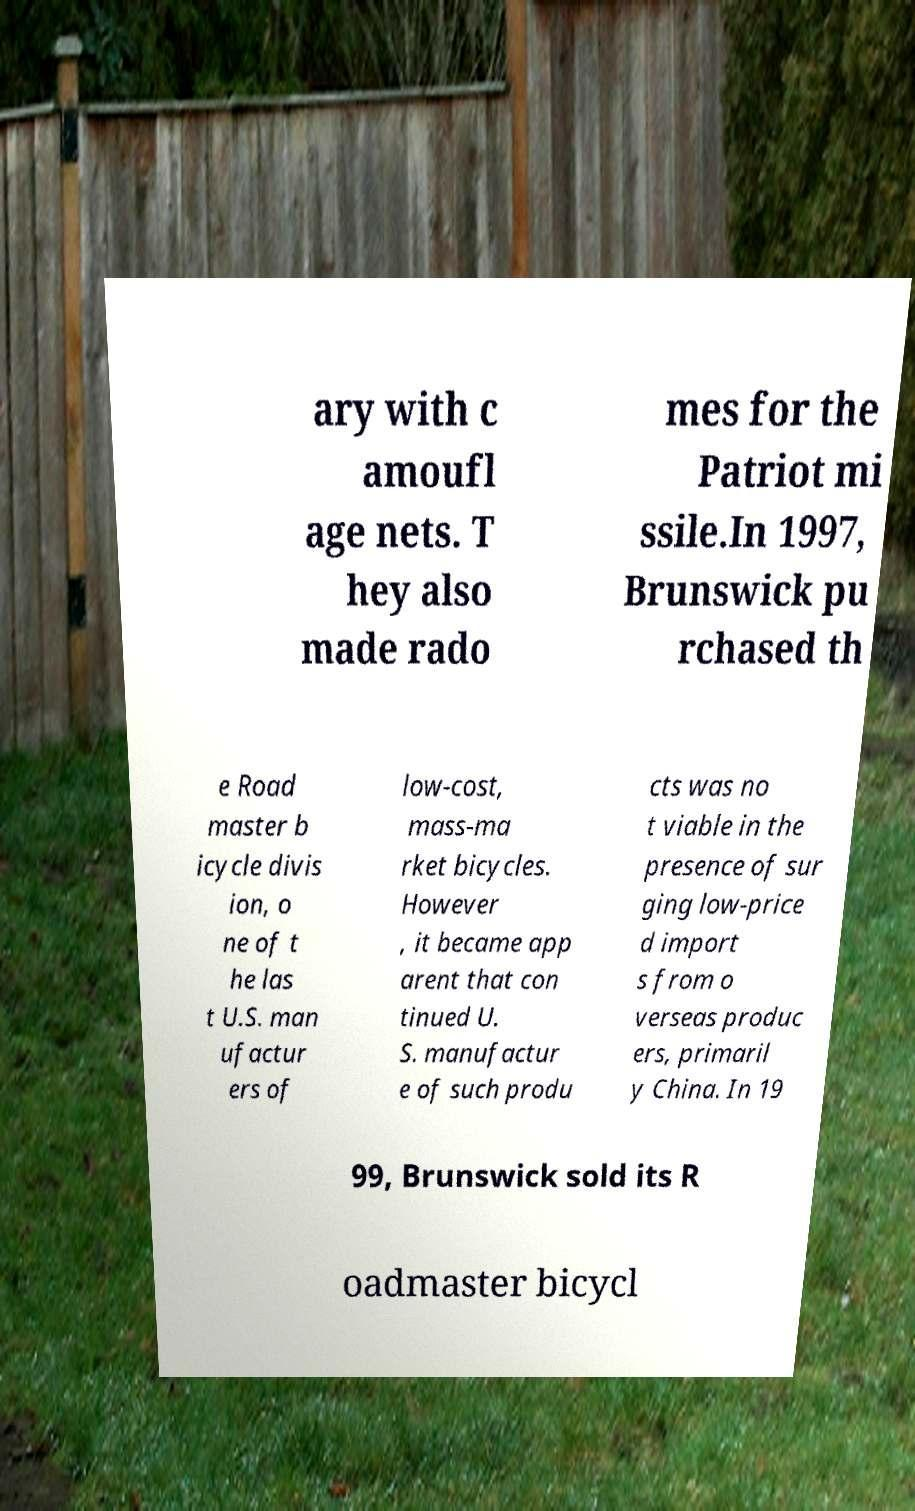I need the written content from this picture converted into text. Can you do that? ary with c amoufl age nets. T hey also made rado mes for the Patriot mi ssile.In 1997, Brunswick pu rchased th e Road master b icycle divis ion, o ne of t he las t U.S. man ufactur ers of low-cost, mass-ma rket bicycles. However , it became app arent that con tinued U. S. manufactur e of such produ cts was no t viable in the presence of sur ging low-price d import s from o verseas produc ers, primaril y China. In 19 99, Brunswick sold its R oadmaster bicycl 